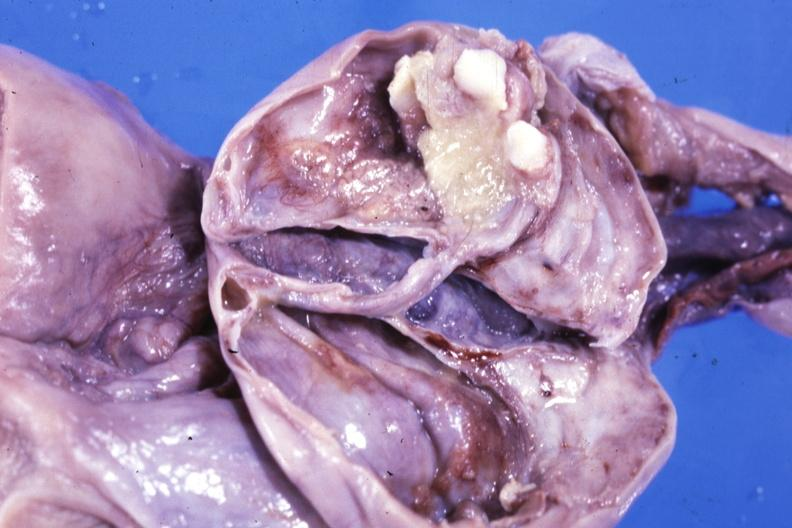what is present?
Answer the question using a single word or phrase. Female reproductive 